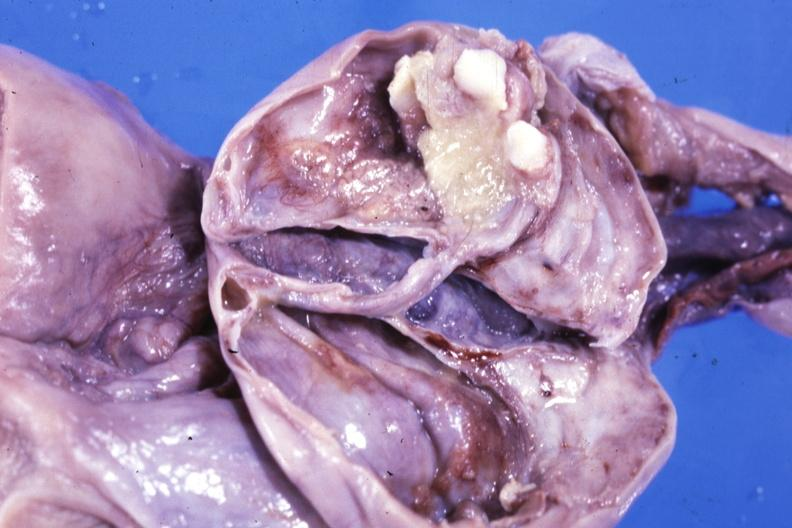what is present?
Answer the question using a single word or phrase. Female reproductive 